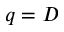<formula> <loc_0><loc_0><loc_500><loc_500>q = D</formula> 